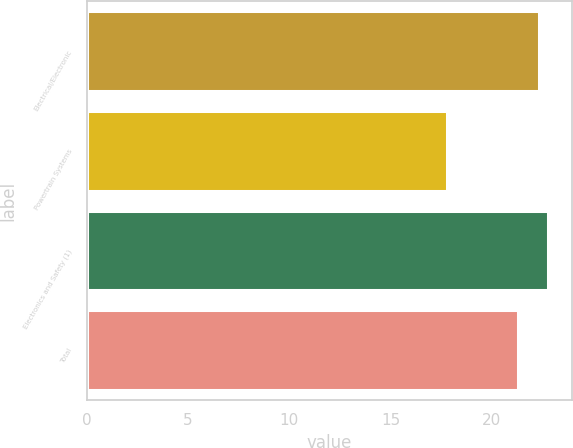Convert chart to OTSL. <chart><loc_0><loc_0><loc_500><loc_500><bar_chart><fcel>Electrical/Electronic<fcel>Powertrain Systems<fcel>Electronics and Safety (1)<fcel>Total<nl><fcel>22.3<fcel>17.8<fcel>22.79<fcel>21.3<nl></chart> 